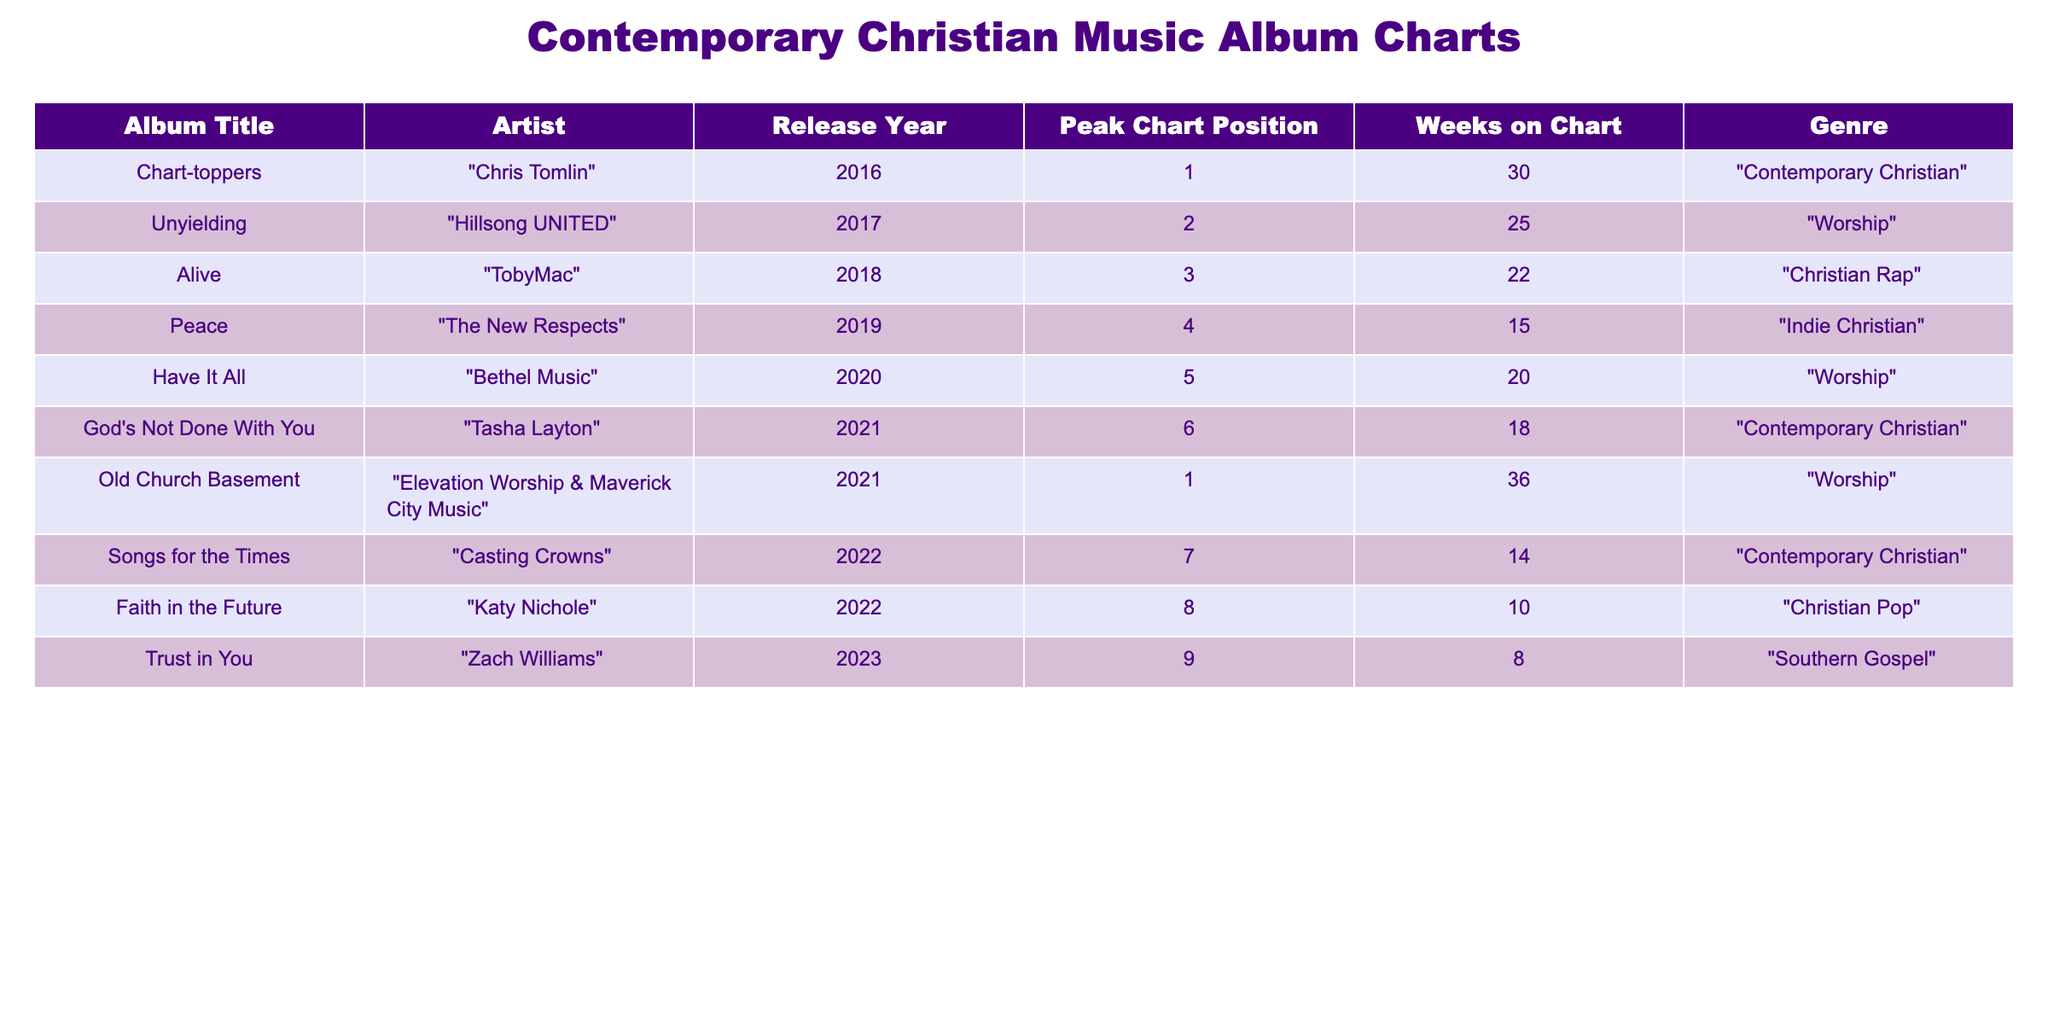What album had the highest peak chart position? Upon reviewing the Peak Chart Position column, "Chart-toppers" by Chris Tomlin has a peak position of 1, which is the highest among all entries.
Answer: "Chart-toppers" How many albums peaked in the top 5? The albums that peaked in the top 5 are "Chart-toppers," "Unyielding," "Alive," "Peace," "Have It All," and "Old Church Basement," totaling 6 albums.
Answer: 6 Which artist had an album that spent the most weeks on the chart? "Old Church Basement" by Elevation Worship & Maverick City Music spent 36 weeks on the chart, which is more than any other album listed.
Answer: "Old Church Basement" Did any album peak at position 8? By checking the Peak Chart Position column, "Faith in the Future" by Katy Nichole reached position 8, confirming that yes, there is an album that peaked at this position.
Answer: Yes Which genre had the most albums represented in the top chart positions? By counting the occurrences in the Genre column, "Worship" appears the most frequently, with 3 albums ("Unyielding," "Have It All," and "Old Church Basement").
Answer: Worship What is the average peak chart position of albums released in 2022? The albums from 2022 are "Songs for the Times" (7) and "Faith in the Future" (8). The average is (7 + 8) / 2 = 7.5.
Answer: 7.5 How many artists released albums in 2021? Only two albums were released in 2021: "God's Not Done With You" by Tasha Layton and "Old Church Basement" by Elevation Worship & Maverick City Music, which implies 2 artists released albums that year.
Answer: 2 Which album had the least amount of weeks on the chart? Looking through the Weeks on Chart column, "Trust in You" by Zach Williams had the least amount of time listed at 8 weeks.
Answer: "Trust in You" Is there any album by Tasha Layton that peaked above position 6? Reviewing the data, the highest peak position listed for "God's Not Done With You" by Tasha Layton is 6, indicating that there is no album by her that peaked above this position.
Answer: No 